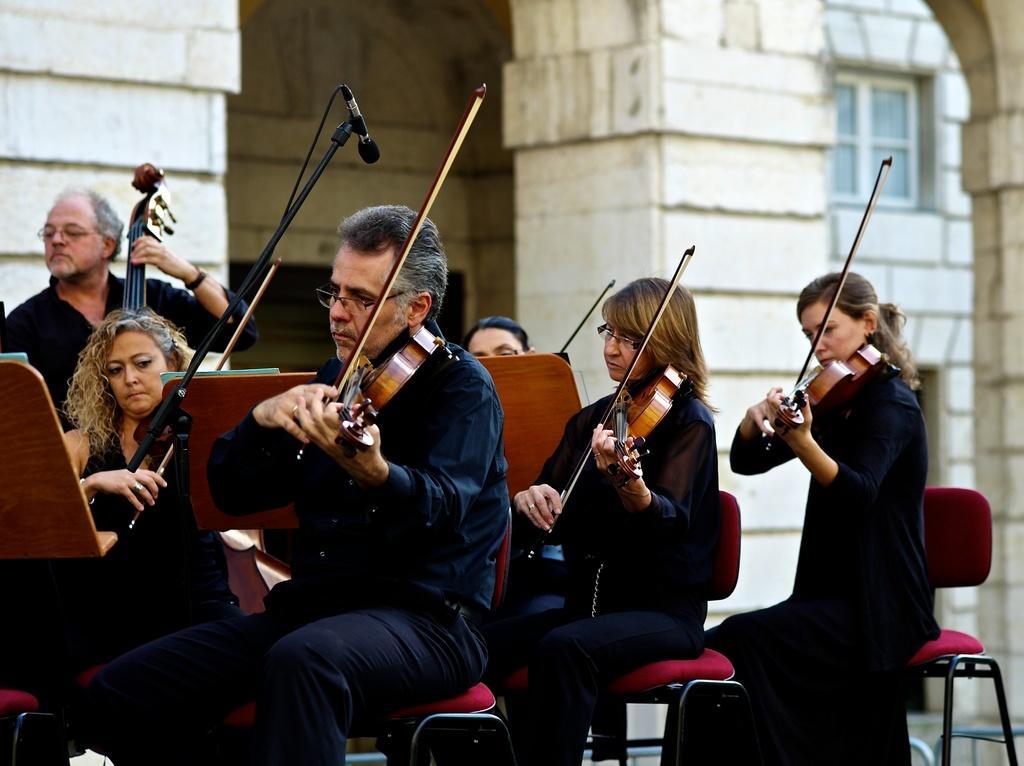Can you describe this image briefly? In this image we can see group of persons sitting on the chairs and holding a violin. In the background there is a building. 